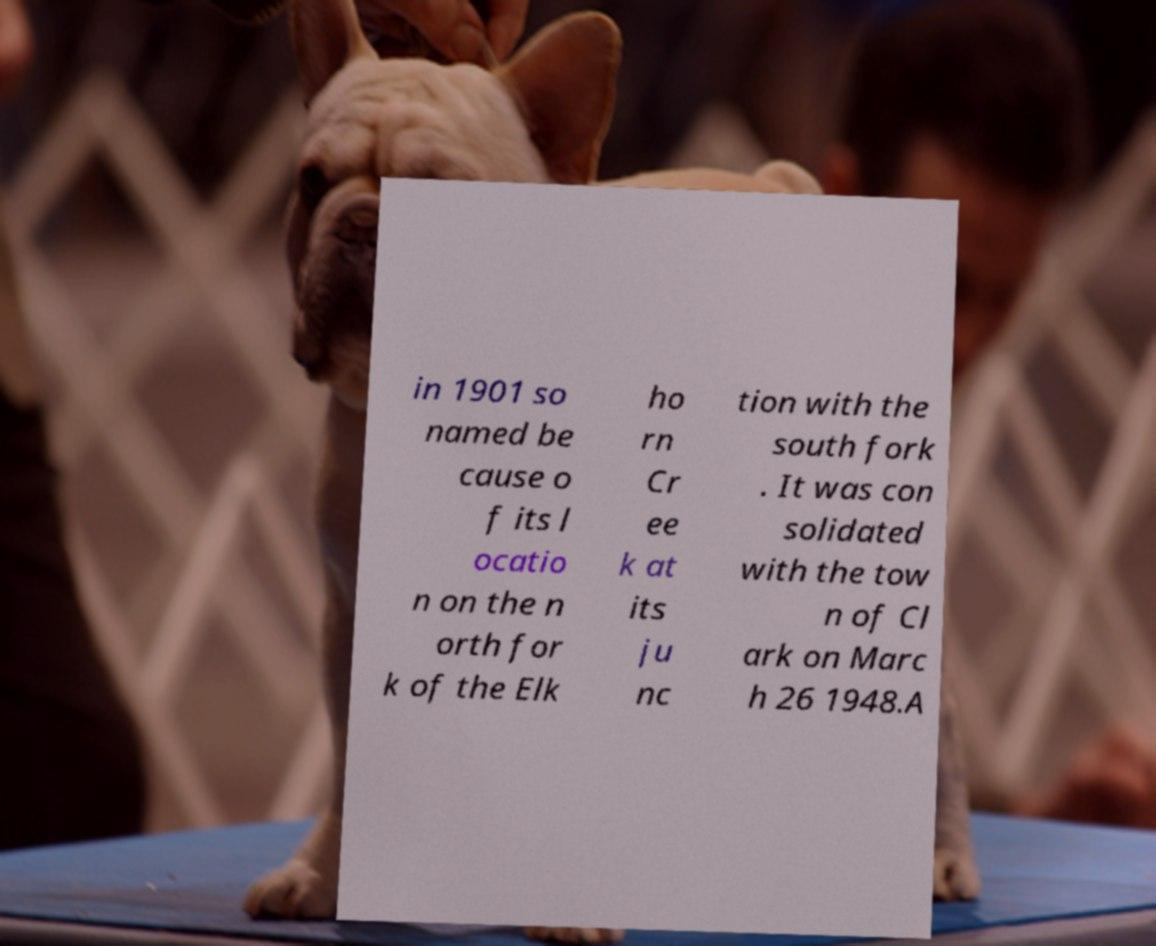Can you read and provide the text displayed in the image?This photo seems to have some interesting text. Can you extract and type it out for me? in 1901 so named be cause o f its l ocatio n on the n orth for k of the Elk ho rn Cr ee k at its ju nc tion with the south fork . It was con solidated with the tow n of Cl ark on Marc h 26 1948.A 